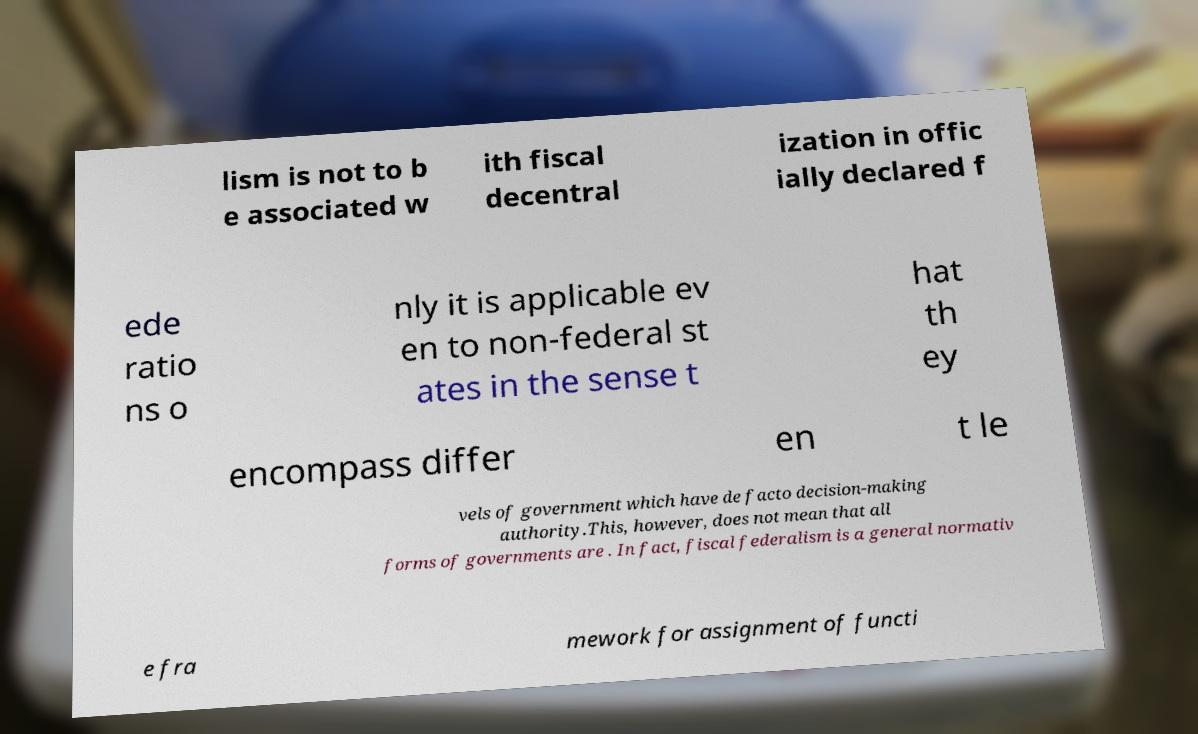What messages or text are displayed in this image? I need them in a readable, typed format. lism is not to b e associated w ith fiscal decentral ization in offic ially declared f ede ratio ns o nly it is applicable ev en to non-federal st ates in the sense t hat th ey encompass differ en t le vels of government which have de facto decision-making authority.This, however, does not mean that all forms of governments are . In fact, fiscal federalism is a general normativ e fra mework for assignment of functi 